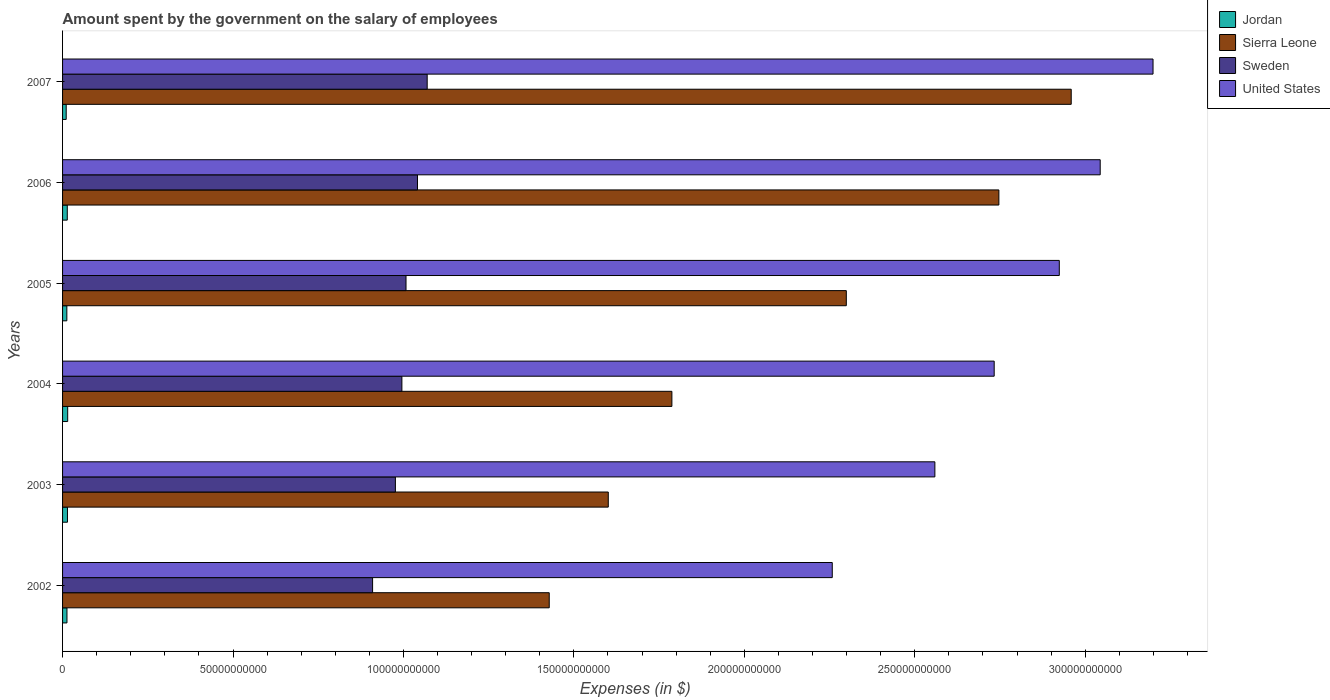How many bars are there on the 4th tick from the top?
Offer a terse response. 4. How many bars are there on the 5th tick from the bottom?
Provide a short and direct response. 4. What is the amount spent on the salary of employees by the government in Jordan in 2006?
Your response must be concise. 1.38e+09. Across all years, what is the maximum amount spent on the salary of employees by the government in Sierra Leone?
Give a very brief answer. 2.96e+11. Across all years, what is the minimum amount spent on the salary of employees by the government in Sweden?
Offer a terse response. 9.09e+1. What is the total amount spent on the salary of employees by the government in Sweden in the graph?
Your answer should be compact. 6.00e+11. What is the difference between the amount spent on the salary of employees by the government in United States in 2002 and that in 2005?
Your answer should be very brief. -6.66e+1. What is the difference between the amount spent on the salary of employees by the government in Sweden in 2004 and the amount spent on the salary of employees by the government in Jordan in 2005?
Keep it short and to the point. 9.83e+1. What is the average amount spent on the salary of employees by the government in Sweden per year?
Offer a terse response. 1.00e+11. In the year 2002, what is the difference between the amount spent on the salary of employees by the government in United States and amount spent on the salary of employees by the government in Sierra Leone?
Offer a very short reply. 8.30e+1. What is the ratio of the amount spent on the salary of employees by the government in Sweden in 2002 to that in 2006?
Ensure brevity in your answer.  0.87. Is the difference between the amount spent on the salary of employees by the government in United States in 2004 and 2007 greater than the difference between the amount spent on the salary of employees by the government in Sierra Leone in 2004 and 2007?
Keep it short and to the point. Yes. What is the difference between the highest and the second highest amount spent on the salary of employees by the government in Jordan?
Keep it short and to the point. 6.46e+07. What is the difference between the highest and the lowest amount spent on the salary of employees by the government in United States?
Provide a succinct answer. 9.41e+1. In how many years, is the amount spent on the salary of employees by the government in Sweden greater than the average amount spent on the salary of employees by the government in Sweden taken over all years?
Provide a succinct answer. 3. What does the 1st bar from the top in 2002 represents?
Your answer should be very brief. United States. Is it the case that in every year, the sum of the amount spent on the salary of employees by the government in Sweden and amount spent on the salary of employees by the government in Jordan is greater than the amount spent on the salary of employees by the government in Sierra Leone?
Offer a very short reply. No. How many years are there in the graph?
Offer a terse response. 6. Does the graph contain any zero values?
Your response must be concise. No. Does the graph contain grids?
Give a very brief answer. No. How many legend labels are there?
Give a very brief answer. 4. What is the title of the graph?
Your answer should be compact. Amount spent by the government on the salary of employees. Does "Guatemala" appear as one of the legend labels in the graph?
Keep it short and to the point. No. What is the label or title of the X-axis?
Your answer should be very brief. Expenses (in $). What is the Expenses (in $) of Jordan in 2002?
Make the answer very short. 1.29e+09. What is the Expenses (in $) of Sierra Leone in 2002?
Your answer should be compact. 1.43e+11. What is the Expenses (in $) of Sweden in 2002?
Provide a succinct answer. 9.09e+1. What is the Expenses (in $) of United States in 2002?
Your answer should be very brief. 2.26e+11. What is the Expenses (in $) in Jordan in 2003?
Your answer should be very brief. 1.44e+09. What is the Expenses (in $) of Sierra Leone in 2003?
Provide a succinct answer. 1.60e+11. What is the Expenses (in $) of Sweden in 2003?
Ensure brevity in your answer.  9.76e+1. What is the Expenses (in $) in United States in 2003?
Your answer should be compact. 2.56e+11. What is the Expenses (in $) in Jordan in 2004?
Your answer should be very brief. 1.50e+09. What is the Expenses (in $) of Sierra Leone in 2004?
Your answer should be compact. 1.79e+11. What is the Expenses (in $) in Sweden in 2004?
Provide a short and direct response. 9.95e+1. What is the Expenses (in $) of United States in 2004?
Your response must be concise. 2.73e+11. What is the Expenses (in $) of Jordan in 2005?
Your answer should be compact. 1.25e+09. What is the Expenses (in $) in Sierra Leone in 2005?
Offer a terse response. 2.30e+11. What is the Expenses (in $) in Sweden in 2005?
Offer a terse response. 1.01e+11. What is the Expenses (in $) in United States in 2005?
Offer a terse response. 2.92e+11. What is the Expenses (in $) in Jordan in 2006?
Make the answer very short. 1.38e+09. What is the Expenses (in $) in Sierra Leone in 2006?
Provide a short and direct response. 2.75e+11. What is the Expenses (in $) in Sweden in 2006?
Provide a succinct answer. 1.04e+11. What is the Expenses (in $) in United States in 2006?
Your response must be concise. 3.04e+11. What is the Expenses (in $) in Jordan in 2007?
Offer a terse response. 1.07e+09. What is the Expenses (in $) of Sierra Leone in 2007?
Provide a short and direct response. 2.96e+11. What is the Expenses (in $) of Sweden in 2007?
Make the answer very short. 1.07e+11. What is the Expenses (in $) in United States in 2007?
Give a very brief answer. 3.20e+11. Across all years, what is the maximum Expenses (in $) of Jordan?
Make the answer very short. 1.50e+09. Across all years, what is the maximum Expenses (in $) in Sierra Leone?
Provide a short and direct response. 2.96e+11. Across all years, what is the maximum Expenses (in $) in Sweden?
Your answer should be compact. 1.07e+11. Across all years, what is the maximum Expenses (in $) of United States?
Ensure brevity in your answer.  3.20e+11. Across all years, what is the minimum Expenses (in $) of Jordan?
Keep it short and to the point. 1.07e+09. Across all years, what is the minimum Expenses (in $) of Sierra Leone?
Offer a very short reply. 1.43e+11. Across all years, what is the minimum Expenses (in $) in Sweden?
Offer a very short reply. 9.09e+1. Across all years, what is the minimum Expenses (in $) of United States?
Offer a terse response. 2.26e+11. What is the total Expenses (in $) of Jordan in the graph?
Give a very brief answer. 7.93e+09. What is the total Expenses (in $) in Sierra Leone in the graph?
Provide a succinct answer. 1.28e+12. What is the total Expenses (in $) in Sweden in the graph?
Make the answer very short. 6.00e+11. What is the total Expenses (in $) of United States in the graph?
Provide a succinct answer. 1.67e+12. What is the difference between the Expenses (in $) of Jordan in 2002 and that in 2003?
Your answer should be very brief. -1.46e+08. What is the difference between the Expenses (in $) in Sierra Leone in 2002 and that in 2003?
Make the answer very short. -1.73e+1. What is the difference between the Expenses (in $) of Sweden in 2002 and that in 2003?
Make the answer very short. -6.69e+09. What is the difference between the Expenses (in $) of United States in 2002 and that in 2003?
Your response must be concise. -3.01e+1. What is the difference between the Expenses (in $) of Jordan in 2002 and that in 2004?
Your answer should be compact. -2.10e+08. What is the difference between the Expenses (in $) in Sierra Leone in 2002 and that in 2004?
Provide a short and direct response. -3.60e+1. What is the difference between the Expenses (in $) in Sweden in 2002 and that in 2004?
Ensure brevity in your answer.  -8.60e+09. What is the difference between the Expenses (in $) in United States in 2002 and that in 2004?
Offer a very short reply. -4.75e+1. What is the difference between the Expenses (in $) in Jordan in 2002 and that in 2005?
Your answer should be compact. 3.66e+07. What is the difference between the Expenses (in $) in Sierra Leone in 2002 and that in 2005?
Provide a succinct answer. -8.72e+1. What is the difference between the Expenses (in $) of Sweden in 2002 and that in 2005?
Your answer should be compact. -9.81e+09. What is the difference between the Expenses (in $) of United States in 2002 and that in 2005?
Your response must be concise. -6.66e+1. What is the difference between the Expenses (in $) of Jordan in 2002 and that in 2006?
Your answer should be compact. -9.21e+07. What is the difference between the Expenses (in $) in Sierra Leone in 2002 and that in 2006?
Provide a short and direct response. -1.32e+11. What is the difference between the Expenses (in $) in Sweden in 2002 and that in 2006?
Offer a very short reply. -1.32e+1. What is the difference between the Expenses (in $) in United States in 2002 and that in 2006?
Provide a short and direct response. -7.86e+1. What is the difference between the Expenses (in $) in Jordan in 2002 and that in 2007?
Ensure brevity in your answer.  2.23e+08. What is the difference between the Expenses (in $) of Sierra Leone in 2002 and that in 2007?
Keep it short and to the point. -1.53e+11. What is the difference between the Expenses (in $) in Sweden in 2002 and that in 2007?
Your answer should be very brief. -1.60e+1. What is the difference between the Expenses (in $) of United States in 2002 and that in 2007?
Keep it short and to the point. -9.41e+1. What is the difference between the Expenses (in $) in Jordan in 2003 and that in 2004?
Your answer should be compact. -6.46e+07. What is the difference between the Expenses (in $) in Sierra Leone in 2003 and that in 2004?
Provide a short and direct response. -1.87e+1. What is the difference between the Expenses (in $) in Sweden in 2003 and that in 2004?
Your response must be concise. -1.91e+09. What is the difference between the Expenses (in $) of United States in 2003 and that in 2004?
Offer a terse response. -1.74e+1. What is the difference between the Expenses (in $) in Jordan in 2003 and that in 2005?
Your answer should be compact. 1.82e+08. What is the difference between the Expenses (in $) in Sierra Leone in 2003 and that in 2005?
Provide a succinct answer. -6.98e+1. What is the difference between the Expenses (in $) in Sweden in 2003 and that in 2005?
Make the answer very short. -3.12e+09. What is the difference between the Expenses (in $) of United States in 2003 and that in 2005?
Make the answer very short. -3.65e+1. What is the difference between the Expenses (in $) in Jordan in 2003 and that in 2006?
Your answer should be very brief. 5.34e+07. What is the difference between the Expenses (in $) in Sierra Leone in 2003 and that in 2006?
Keep it short and to the point. -1.15e+11. What is the difference between the Expenses (in $) of Sweden in 2003 and that in 2006?
Provide a succinct answer. -6.48e+09. What is the difference between the Expenses (in $) in United States in 2003 and that in 2006?
Keep it short and to the point. -4.85e+1. What is the difference between the Expenses (in $) in Jordan in 2003 and that in 2007?
Make the answer very short. 3.69e+08. What is the difference between the Expenses (in $) in Sierra Leone in 2003 and that in 2007?
Offer a very short reply. -1.36e+11. What is the difference between the Expenses (in $) in Sweden in 2003 and that in 2007?
Ensure brevity in your answer.  -9.33e+09. What is the difference between the Expenses (in $) in United States in 2003 and that in 2007?
Your response must be concise. -6.40e+1. What is the difference between the Expenses (in $) in Jordan in 2004 and that in 2005?
Offer a very short reply. 2.47e+08. What is the difference between the Expenses (in $) in Sierra Leone in 2004 and that in 2005?
Your answer should be compact. -5.12e+1. What is the difference between the Expenses (in $) of Sweden in 2004 and that in 2005?
Offer a terse response. -1.21e+09. What is the difference between the Expenses (in $) in United States in 2004 and that in 2005?
Provide a short and direct response. -1.91e+1. What is the difference between the Expenses (in $) of Jordan in 2004 and that in 2006?
Ensure brevity in your answer.  1.18e+08. What is the difference between the Expenses (in $) of Sierra Leone in 2004 and that in 2006?
Your answer should be compact. -9.59e+1. What is the difference between the Expenses (in $) of Sweden in 2004 and that in 2006?
Your answer should be compact. -4.57e+09. What is the difference between the Expenses (in $) of United States in 2004 and that in 2006?
Provide a short and direct response. -3.11e+1. What is the difference between the Expenses (in $) in Jordan in 2004 and that in 2007?
Your answer should be very brief. 4.33e+08. What is the difference between the Expenses (in $) of Sierra Leone in 2004 and that in 2007?
Keep it short and to the point. -1.17e+11. What is the difference between the Expenses (in $) in Sweden in 2004 and that in 2007?
Give a very brief answer. -7.42e+09. What is the difference between the Expenses (in $) in United States in 2004 and that in 2007?
Make the answer very short. -4.66e+1. What is the difference between the Expenses (in $) of Jordan in 2005 and that in 2006?
Your answer should be compact. -1.29e+08. What is the difference between the Expenses (in $) of Sierra Leone in 2005 and that in 2006?
Make the answer very short. -4.48e+1. What is the difference between the Expenses (in $) in Sweden in 2005 and that in 2006?
Make the answer very short. -3.36e+09. What is the difference between the Expenses (in $) in United States in 2005 and that in 2006?
Make the answer very short. -1.20e+1. What is the difference between the Expenses (in $) in Jordan in 2005 and that in 2007?
Keep it short and to the point. 1.86e+08. What is the difference between the Expenses (in $) of Sierra Leone in 2005 and that in 2007?
Your response must be concise. -6.60e+1. What is the difference between the Expenses (in $) of Sweden in 2005 and that in 2007?
Make the answer very short. -6.21e+09. What is the difference between the Expenses (in $) in United States in 2005 and that in 2007?
Provide a succinct answer. -2.75e+1. What is the difference between the Expenses (in $) in Jordan in 2006 and that in 2007?
Ensure brevity in your answer.  3.15e+08. What is the difference between the Expenses (in $) in Sierra Leone in 2006 and that in 2007?
Provide a short and direct response. -2.12e+1. What is the difference between the Expenses (in $) in Sweden in 2006 and that in 2007?
Your response must be concise. -2.85e+09. What is the difference between the Expenses (in $) in United States in 2006 and that in 2007?
Provide a succinct answer. -1.55e+1. What is the difference between the Expenses (in $) of Jordan in 2002 and the Expenses (in $) of Sierra Leone in 2003?
Keep it short and to the point. -1.59e+11. What is the difference between the Expenses (in $) of Jordan in 2002 and the Expenses (in $) of Sweden in 2003?
Ensure brevity in your answer.  -9.63e+1. What is the difference between the Expenses (in $) in Jordan in 2002 and the Expenses (in $) in United States in 2003?
Your answer should be compact. -2.55e+11. What is the difference between the Expenses (in $) of Sierra Leone in 2002 and the Expenses (in $) of Sweden in 2003?
Your response must be concise. 4.51e+1. What is the difference between the Expenses (in $) in Sierra Leone in 2002 and the Expenses (in $) in United States in 2003?
Give a very brief answer. -1.13e+11. What is the difference between the Expenses (in $) in Sweden in 2002 and the Expenses (in $) in United States in 2003?
Your answer should be compact. -1.65e+11. What is the difference between the Expenses (in $) of Jordan in 2002 and the Expenses (in $) of Sierra Leone in 2004?
Ensure brevity in your answer.  -1.77e+11. What is the difference between the Expenses (in $) of Jordan in 2002 and the Expenses (in $) of Sweden in 2004?
Make the answer very short. -9.83e+1. What is the difference between the Expenses (in $) of Jordan in 2002 and the Expenses (in $) of United States in 2004?
Offer a very short reply. -2.72e+11. What is the difference between the Expenses (in $) in Sierra Leone in 2002 and the Expenses (in $) in Sweden in 2004?
Your answer should be very brief. 4.32e+1. What is the difference between the Expenses (in $) in Sierra Leone in 2002 and the Expenses (in $) in United States in 2004?
Your answer should be compact. -1.31e+11. What is the difference between the Expenses (in $) in Sweden in 2002 and the Expenses (in $) in United States in 2004?
Your answer should be compact. -1.82e+11. What is the difference between the Expenses (in $) in Jordan in 2002 and the Expenses (in $) in Sierra Leone in 2005?
Offer a very short reply. -2.29e+11. What is the difference between the Expenses (in $) of Jordan in 2002 and the Expenses (in $) of Sweden in 2005?
Provide a short and direct response. -9.95e+1. What is the difference between the Expenses (in $) of Jordan in 2002 and the Expenses (in $) of United States in 2005?
Ensure brevity in your answer.  -2.91e+11. What is the difference between the Expenses (in $) of Sierra Leone in 2002 and the Expenses (in $) of Sweden in 2005?
Ensure brevity in your answer.  4.20e+1. What is the difference between the Expenses (in $) of Sierra Leone in 2002 and the Expenses (in $) of United States in 2005?
Your response must be concise. -1.50e+11. What is the difference between the Expenses (in $) of Sweden in 2002 and the Expenses (in $) of United States in 2005?
Make the answer very short. -2.01e+11. What is the difference between the Expenses (in $) in Jordan in 2002 and the Expenses (in $) in Sierra Leone in 2006?
Your answer should be very brief. -2.73e+11. What is the difference between the Expenses (in $) of Jordan in 2002 and the Expenses (in $) of Sweden in 2006?
Offer a terse response. -1.03e+11. What is the difference between the Expenses (in $) in Jordan in 2002 and the Expenses (in $) in United States in 2006?
Provide a short and direct response. -3.03e+11. What is the difference between the Expenses (in $) in Sierra Leone in 2002 and the Expenses (in $) in Sweden in 2006?
Give a very brief answer. 3.87e+1. What is the difference between the Expenses (in $) in Sierra Leone in 2002 and the Expenses (in $) in United States in 2006?
Offer a very short reply. -1.62e+11. What is the difference between the Expenses (in $) of Sweden in 2002 and the Expenses (in $) of United States in 2006?
Your response must be concise. -2.13e+11. What is the difference between the Expenses (in $) in Jordan in 2002 and the Expenses (in $) in Sierra Leone in 2007?
Offer a very short reply. -2.95e+11. What is the difference between the Expenses (in $) of Jordan in 2002 and the Expenses (in $) of Sweden in 2007?
Give a very brief answer. -1.06e+11. What is the difference between the Expenses (in $) in Jordan in 2002 and the Expenses (in $) in United States in 2007?
Your answer should be very brief. -3.19e+11. What is the difference between the Expenses (in $) of Sierra Leone in 2002 and the Expenses (in $) of Sweden in 2007?
Make the answer very short. 3.58e+1. What is the difference between the Expenses (in $) of Sierra Leone in 2002 and the Expenses (in $) of United States in 2007?
Your answer should be compact. -1.77e+11. What is the difference between the Expenses (in $) of Sweden in 2002 and the Expenses (in $) of United States in 2007?
Your answer should be very brief. -2.29e+11. What is the difference between the Expenses (in $) in Jordan in 2003 and the Expenses (in $) in Sierra Leone in 2004?
Make the answer very short. -1.77e+11. What is the difference between the Expenses (in $) of Jordan in 2003 and the Expenses (in $) of Sweden in 2004?
Provide a short and direct response. -9.81e+1. What is the difference between the Expenses (in $) in Jordan in 2003 and the Expenses (in $) in United States in 2004?
Provide a short and direct response. -2.72e+11. What is the difference between the Expenses (in $) of Sierra Leone in 2003 and the Expenses (in $) of Sweden in 2004?
Give a very brief answer. 6.05e+1. What is the difference between the Expenses (in $) in Sierra Leone in 2003 and the Expenses (in $) in United States in 2004?
Provide a succinct answer. -1.13e+11. What is the difference between the Expenses (in $) in Sweden in 2003 and the Expenses (in $) in United States in 2004?
Give a very brief answer. -1.76e+11. What is the difference between the Expenses (in $) of Jordan in 2003 and the Expenses (in $) of Sierra Leone in 2005?
Provide a short and direct response. -2.28e+11. What is the difference between the Expenses (in $) in Jordan in 2003 and the Expenses (in $) in Sweden in 2005?
Your answer should be very brief. -9.93e+1. What is the difference between the Expenses (in $) of Jordan in 2003 and the Expenses (in $) of United States in 2005?
Offer a terse response. -2.91e+11. What is the difference between the Expenses (in $) of Sierra Leone in 2003 and the Expenses (in $) of Sweden in 2005?
Give a very brief answer. 5.93e+1. What is the difference between the Expenses (in $) of Sierra Leone in 2003 and the Expenses (in $) of United States in 2005?
Provide a short and direct response. -1.32e+11. What is the difference between the Expenses (in $) in Sweden in 2003 and the Expenses (in $) in United States in 2005?
Your answer should be very brief. -1.95e+11. What is the difference between the Expenses (in $) in Jordan in 2003 and the Expenses (in $) in Sierra Leone in 2006?
Your answer should be compact. -2.73e+11. What is the difference between the Expenses (in $) of Jordan in 2003 and the Expenses (in $) of Sweden in 2006?
Ensure brevity in your answer.  -1.03e+11. What is the difference between the Expenses (in $) of Jordan in 2003 and the Expenses (in $) of United States in 2006?
Provide a succinct answer. -3.03e+11. What is the difference between the Expenses (in $) of Sierra Leone in 2003 and the Expenses (in $) of Sweden in 2006?
Keep it short and to the point. 5.60e+1. What is the difference between the Expenses (in $) of Sierra Leone in 2003 and the Expenses (in $) of United States in 2006?
Keep it short and to the point. -1.44e+11. What is the difference between the Expenses (in $) of Sweden in 2003 and the Expenses (in $) of United States in 2006?
Make the answer very short. -2.07e+11. What is the difference between the Expenses (in $) in Jordan in 2003 and the Expenses (in $) in Sierra Leone in 2007?
Offer a very short reply. -2.94e+11. What is the difference between the Expenses (in $) of Jordan in 2003 and the Expenses (in $) of Sweden in 2007?
Ensure brevity in your answer.  -1.06e+11. What is the difference between the Expenses (in $) of Jordan in 2003 and the Expenses (in $) of United States in 2007?
Make the answer very short. -3.18e+11. What is the difference between the Expenses (in $) of Sierra Leone in 2003 and the Expenses (in $) of Sweden in 2007?
Ensure brevity in your answer.  5.31e+1. What is the difference between the Expenses (in $) of Sierra Leone in 2003 and the Expenses (in $) of United States in 2007?
Provide a succinct answer. -1.60e+11. What is the difference between the Expenses (in $) of Sweden in 2003 and the Expenses (in $) of United States in 2007?
Your answer should be compact. -2.22e+11. What is the difference between the Expenses (in $) of Jordan in 2004 and the Expenses (in $) of Sierra Leone in 2005?
Offer a terse response. -2.28e+11. What is the difference between the Expenses (in $) of Jordan in 2004 and the Expenses (in $) of Sweden in 2005?
Make the answer very short. -9.93e+1. What is the difference between the Expenses (in $) of Jordan in 2004 and the Expenses (in $) of United States in 2005?
Give a very brief answer. -2.91e+11. What is the difference between the Expenses (in $) in Sierra Leone in 2004 and the Expenses (in $) in Sweden in 2005?
Your answer should be compact. 7.80e+1. What is the difference between the Expenses (in $) in Sierra Leone in 2004 and the Expenses (in $) in United States in 2005?
Give a very brief answer. -1.14e+11. What is the difference between the Expenses (in $) of Sweden in 2004 and the Expenses (in $) of United States in 2005?
Your answer should be compact. -1.93e+11. What is the difference between the Expenses (in $) of Jordan in 2004 and the Expenses (in $) of Sierra Leone in 2006?
Offer a terse response. -2.73e+11. What is the difference between the Expenses (in $) in Jordan in 2004 and the Expenses (in $) in Sweden in 2006?
Offer a very short reply. -1.03e+11. What is the difference between the Expenses (in $) of Jordan in 2004 and the Expenses (in $) of United States in 2006?
Offer a terse response. -3.03e+11. What is the difference between the Expenses (in $) in Sierra Leone in 2004 and the Expenses (in $) in Sweden in 2006?
Keep it short and to the point. 7.46e+1. What is the difference between the Expenses (in $) in Sierra Leone in 2004 and the Expenses (in $) in United States in 2006?
Your answer should be very brief. -1.26e+11. What is the difference between the Expenses (in $) in Sweden in 2004 and the Expenses (in $) in United States in 2006?
Give a very brief answer. -2.05e+11. What is the difference between the Expenses (in $) of Jordan in 2004 and the Expenses (in $) of Sierra Leone in 2007?
Offer a terse response. -2.94e+11. What is the difference between the Expenses (in $) of Jordan in 2004 and the Expenses (in $) of Sweden in 2007?
Provide a short and direct response. -1.05e+11. What is the difference between the Expenses (in $) of Jordan in 2004 and the Expenses (in $) of United States in 2007?
Keep it short and to the point. -3.18e+11. What is the difference between the Expenses (in $) in Sierra Leone in 2004 and the Expenses (in $) in Sweden in 2007?
Ensure brevity in your answer.  7.18e+1. What is the difference between the Expenses (in $) in Sierra Leone in 2004 and the Expenses (in $) in United States in 2007?
Offer a terse response. -1.41e+11. What is the difference between the Expenses (in $) of Sweden in 2004 and the Expenses (in $) of United States in 2007?
Offer a terse response. -2.20e+11. What is the difference between the Expenses (in $) of Jordan in 2005 and the Expenses (in $) of Sierra Leone in 2006?
Make the answer very short. -2.73e+11. What is the difference between the Expenses (in $) of Jordan in 2005 and the Expenses (in $) of Sweden in 2006?
Your answer should be compact. -1.03e+11. What is the difference between the Expenses (in $) of Jordan in 2005 and the Expenses (in $) of United States in 2006?
Provide a short and direct response. -3.03e+11. What is the difference between the Expenses (in $) of Sierra Leone in 2005 and the Expenses (in $) of Sweden in 2006?
Make the answer very short. 1.26e+11. What is the difference between the Expenses (in $) of Sierra Leone in 2005 and the Expenses (in $) of United States in 2006?
Your response must be concise. -7.45e+1. What is the difference between the Expenses (in $) in Sweden in 2005 and the Expenses (in $) in United States in 2006?
Ensure brevity in your answer.  -2.04e+11. What is the difference between the Expenses (in $) of Jordan in 2005 and the Expenses (in $) of Sierra Leone in 2007?
Offer a terse response. -2.95e+11. What is the difference between the Expenses (in $) of Jordan in 2005 and the Expenses (in $) of Sweden in 2007?
Your response must be concise. -1.06e+11. What is the difference between the Expenses (in $) of Jordan in 2005 and the Expenses (in $) of United States in 2007?
Provide a short and direct response. -3.19e+11. What is the difference between the Expenses (in $) of Sierra Leone in 2005 and the Expenses (in $) of Sweden in 2007?
Keep it short and to the point. 1.23e+11. What is the difference between the Expenses (in $) in Sierra Leone in 2005 and the Expenses (in $) in United States in 2007?
Provide a short and direct response. -9.00e+1. What is the difference between the Expenses (in $) in Sweden in 2005 and the Expenses (in $) in United States in 2007?
Keep it short and to the point. -2.19e+11. What is the difference between the Expenses (in $) of Jordan in 2006 and the Expenses (in $) of Sierra Leone in 2007?
Give a very brief answer. -2.95e+11. What is the difference between the Expenses (in $) in Jordan in 2006 and the Expenses (in $) in Sweden in 2007?
Offer a very short reply. -1.06e+11. What is the difference between the Expenses (in $) in Jordan in 2006 and the Expenses (in $) in United States in 2007?
Give a very brief answer. -3.19e+11. What is the difference between the Expenses (in $) in Sierra Leone in 2006 and the Expenses (in $) in Sweden in 2007?
Your answer should be very brief. 1.68e+11. What is the difference between the Expenses (in $) of Sierra Leone in 2006 and the Expenses (in $) of United States in 2007?
Your answer should be compact. -4.52e+1. What is the difference between the Expenses (in $) of Sweden in 2006 and the Expenses (in $) of United States in 2007?
Give a very brief answer. -2.16e+11. What is the average Expenses (in $) in Jordan per year?
Provide a succinct answer. 1.32e+09. What is the average Expenses (in $) in Sierra Leone per year?
Your answer should be very brief. 2.14e+11. What is the average Expenses (in $) in Sweden per year?
Make the answer very short. 1.00e+11. What is the average Expenses (in $) in United States per year?
Ensure brevity in your answer.  2.79e+11. In the year 2002, what is the difference between the Expenses (in $) in Jordan and Expenses (in $) in Sierra Leone?
Your response must be concise. -1.41e+11. In the year 2002, what is the difference between the Expenses (in $) of Jordan and Expenses (in $) of Sweden?
Your answer should be very brief. -8.97e+1. In the year 2002, what is the difference between the Expenses (in $) in Jordan and Expenses (in $) in United States?
Give a very brief answer. -2.25e+11. In the year 2002, what is the difference between the Expenses (in $) in Sierra Leone and Expenses (in $) in Sweden?
Keep it short and to the point. 5.18e+1. In the year 2002, what is the difference between the Expenses (in $) in Sierra Leone and Expenses (in $) in United States?
Provide a short and direct response. -8.30e+1. In the year 2002, what is the difference between the Expenses (in $) of Sweden and Expenses (in $) of United States?
Your response must be concise. -1.35e+11. In the year 2003, what is the difference between the Expenses (in $) in Jordan and Expenses (in $) in Sierra Leone?
Provide a short and direct response. -1.59e+11. In the year 2003, what is the difference between the Expenses (in $) of Jordan and Expenses (in $) of Sweden?
Your answer should be compact. -9.62e+1. In the year 2003, what is the difference between the Expenses (in $) in Jordan and Expenses (in $) in United States?
Give a very brief answer. -2.54e+11. In the year 2003, what is the difference between the Expenses (in $) in Sierra Leone and Expenses (in $) in Sweden?
Make the answer very short. 6.25e+1. In the year 2003, what is the difference between the Expenses (in $) in Sierra Leone and Expenses (in $) in United States?
Provide a short and direct response. -9.58e+1. In the year 2003, what is the difference between the Expenses (in $) of Sweden and Expenses (in $) of United States?
Provide a succinct answer. -1.58e+11. In the year 2004, what is the difference between the Expenses (in $) in Jordan and Expenses (in $) in Sierra Leone?
Your answer should be very brief. -1.77e+11. In the year 2004, what is the difference between the Expenses (in $) in Jordan and Expenses (in $) in Sweden?
Keep it short and to the point. -9.80e+1. In the year 2004, what is the difference between the Expenses (in $) in Jordan and Expenses (in $) in United States?
Your answer should be very brief. -2.72e+11. In the year 2004, what is the difference between the Expenses (in $) in Sierra Leone and Expenses (in $) in Sweden?
Your answer should be compact. 7.92e+1. In the year 2004, what is the difference between the Expenses (in $) in Sierra Leone and Expenses (in $) in United States?
Your answer should be compact. -9.45e+1. In the year 2004, what is the difference between the Expenses (in $) of Sweden and Expenses (in $) of United States?
Your answer should be compact. -1.74e+11. In the year 2005, what is the difference between the Expenses (in $) in Jordan and Expenses (in $) in Sierra Leone?
Keep it short and to the point. -2.29e+11. In the year 2005, what is the difference between the Expenses (in $) in Jordan and Expenses (in $) in Sweden?
Provide a succinct answer. -9.95e+1. In the year 2005, what is the difference between the Expenses (in $) of Jordan and Expenses (in $) of United States?
Ensure brevity in your answer.  -2.91e+11. In the year 2005, what is the difference between the Expenses (in $) in Sierra Leone and Expenses (in $) in Sweden?
Provide a succinct answer. 1.29e+11. In the year 2005, what is the difference between the Expenses (in $) of Sierra Leone and Expenses (in $) of United States?
Offer a terse response. -6.25e+1. In the year 2005, what is the difference between the Expenses (in $) of Sweden and Expenses (in $) of United States?
Provide a succinct answer. -1.92e+11. In the year 2006, what is the difference between the Expenses (in $) of Jordan and Expenses (in $) of Sierra Leone?
Make the answer very short. -2.73e+11. In the year 2006, what is the difference between the Expenses (in $) in Jordan and Expenses (in $) in Sweden?
Offer a very short reply. -1.03e+11. In the year 2006, what is the difference between the Expenses (in $) of Jordan and Expenses (in $) of United States?
Provide a succinct answer. -3.03e+11. In the year 2006, what is the difference between the Expenses (in $) in Sierra Leone and Expenses (in $) in Sweden?
Your response must be concise. 1.71e+11. In the year 2006, what is the difference between the Expenses (in $) in Sierra Leone and Expenses (in $) in United States?
Give a very brief answer. -2.97e+1. In the year 2006, what is the difference between the Expenses (in $) in Sweden and Expenses (in $) in United States?
Offer a terse response. -2.00e+11. In the year 2007, what is the difference between the Expenses (in $) of Jordan and Expenses (in $) of Sierra Leone?
Your response must be concise. -2.95e+11. In the year 2007, what is the difference between the Expenses (in $) in Jordan and Expenses (in $) in Sweden?
Make the answer very short. -1.06e+11. In the year 2007, what is the difference between the Expenses (in $) in Jordan and Expenses (in $) in United States?
Your answer should be very brief. -3.19e+11. In the year 2007, what is the difference between the Expenses (in $) in Sierra Leone and Expenses (in $) in Sweden?
Provide a succinct answer. 1.89e+11. In the year 2007, what is the difference between the Expenses (in $) of Sierra Leone and Expenses (in $) of United States?
Give a very brief answer. -2.40e+1. In the year 2007, what is the difference between the Expenses (in $) of Sweden and Expenses (in $) of United States?
Make the answer very short. -2.13e+11. What is the ratio of the Expenses (in $) in Jordan in 2002 to that in 2003?
Your response must be concise. 0.9. What is the ratio of the Expenses (in $) of Sierra Leone in 2002 to that in 2003?
Ensure brevity in your answer.  0.89. What is the ratio of the Expenses (in $) in Sweden in 2002 to that in 2003?
Your answer should be very brief. 0.93. What is the ratio of the Expenses (in $) in United States in 2002 to that in 2003?
Ensure brevity in your answer.  0.88. What is the ratio of the Expenses (in $) of Jordan in 2002 to that in 2004?
Give a very brief answer. 0.86. What is the ratio of the Expenses (in $) of Sierra Leone in 2002 to that in 2004?
Make the answer very short. 0.8. What is the ratio of the Expenses (in $) of Sweden in 2002 to that in 2004?
Your answer should be very brief. 0.91. What is the ratio of the Expenses (in $) in United States in 2002 to that in 2004?
Offer a terse response. 0.83. What is the ratio of the Expenses (in $) of Jordan in 2002 to that in 2005?
Provide a succinct answer. 1.03. What is the ratio of the Expenses (in $) of Sierra Leone in 2002 to that in 2005?
Your answer should be very brief. 0.62. What is the ratio of the Expenses (in $) in Sweden in 2002 to that in 2005?
Offer a very short reply. 0.9. What is the ratio of the Expenses (in $) of United States in 2002 to that in 2005?
Provide a succinct answer. 0.77. What is the ratio of the Expenses (in $) of Jordan in 2002 to that in 2006?
Your answer should be compact. 0.93. What is the ratio of the Expenses (in $) of Sierra Leone in 2002 to that in 2006?
Your answer should be very brief. 0.52. What is the ratio of the Expenses (in $) in Sweden in 2002 to that in 2006?
Offer a very short reply. 0.87. What is the ratio of the Expenses (in $) of United States in 2002 to that in 2006?
Provide a succinct answer. 0.74. What is the ratio of the Expenses (in $) of Jordan in 2002 to that in 2007?
Your answer should be very brief. 1.21. What is the ratio of the Expenses (in $) in Sierra Leone in 2002 to that in 2007?
Offer a terse response. 0.48. What is the ratio of the Expenses (in $) of Sweden in 2002 to that in 2007?
Your answer should be very brief. 0.85. What is the ratio of the Expenses (in $) of United States in 2002 to that in 2007?
Offer a very short reply. 0.71. What is the ratio of the Expenses (in $) in Jordan in 2003 to that in 2004?
Your response must be concise. 0.96. What is the ratio of the Expenses (in $) of Sierra Leone in 2003 to that in 2004?
Offer a terse response. 0.9. What is the ratio of the Expenses (in $) of Sweden in 2003 to that in 2004?
Keep it short and to the point. 0.98. What is the ratio of the Expenses (in $) of United States in 2003 to that in 2004?
Your response must be concise. 0.94. What is the ratio of the Expenses (in $) in Jordan in 2003 to that in 2005?
Offer a very short reply. 1.15. What is the ratio of the Expenses (in $) of Sierra Leone in 2003 to that in 2005?
Provide a succinct answer. 0.7. What is the ratio of the Expenses (in $) of Sweden in 2003 to that in 2005?
Provide a short and direct response. 0.97. What is the ratio of the Expenses (in $) in United States in 2003 to that in 2005?
Give a very brief answer. 0.88. What is the ratio of the Expenses (in $) in Jordan in 2003 to that in 2006?
Provide a short and direct response. 1.04. What is the ratio of the Expenses (in $) of Sierra Leone in 2003 to that in 2006?
Keep it short and to the point. 0.58. What is the ratio of the Expenses (in $) of Sweden in 2003 to that in 2006?
Offer a very short reply. 0.94. What is the ratio of the Expenses (in $) of United States in 2003 to that in 2006?
Provide a succinct answer. 0.84. What is the ratio of the Expenses (in $) of Jordan in 2003 to that in 2007?
Provide a short and direct response. 1.35. What is the ratio of the Expenses (in $) in Sierra Leone in 2003 to that in 2007?
Your response must be concise. 0.54. What is the ratio of the Expenses (in $) in Sweden in 2003 to that in 2007?
Offer a very short reply. 0.91. What is the ratio of the Expenses (in $) in United States in 2003 to that in 2007?
Give a very brief answer. 0.8. What is the ratio of the Expenses (in $) in Jordan in 2004 to that in 2005?
Offer a very short reply. 1.2. What is the ratio of the Expenses (in $) of Sierra Leone in 2004 to that in 2005?
Provide a succinct answer. 0.78. What is the ratio of the Expenses (in $) of Sweden in 2004 to that in 2005?
Your answer should be very brief. 0.99. What is the ratio of the Expenses (in $) in United States in 2004 to that in 2005?
Keep it short and to the point. 0.93. What is the ratio of the Expenses (in $) of Jordan in 2004 to that in 2006?
Your answer should be compact. 1.09. What is the ratio of the Expenses (in $) in Sierra Leone in 2004 to that in 2006?
Provide a succinct answer. 0.65. What is the ratio of the Expenses (in $) in Sweden in 2004 to that in 2006?
Give a very brief answer. 0.96. What is the ratio of the Expenses (in $) in United States in 2004 to that in 2006?
Offer a terse response. 0.9. What is the ratio of the Expenses (in $) in Jordan in 2004 to that in 2007?
Offer a terse response. 1.41. What is the ratio of the Expenses (in $) of Sierra Leone in 2004 to that in 2007?
Ensure brevity in your answer.  0.6. What is the ratio of the Expenses (in $) of Sweden in 2004 to that in 2007?
Your answer should be very brief. 0.93. What is the ratio of the Expenses (in $) of United States in 2004 to that in 2007?
Offer a very short reply. 0.85. What is the ratio of the Expenses (in $) in Jordan in 2005 to that in 2006?
Give a very brief answer. 0.91. What is the ratio of the Expenses (in $) of Sierra Leone in 2005 to that in 2006?
Your response must be concise. 0.84. What is the ratio of the Expenses (in $) in United States in 2005 to that in 2006?
Offer a very short reply. 0.96. What is the ratio of the Expenses (in $) of Jordan in 2005 to that in 2007?
Your response must be concise. 1.17. What is the ratio of the Expenses (in $) in Sierra Leone in 2005 to that in 2007?
Offer a terse response. 0.78. What is the ratio of the Expenses (in $) of Sweden in 2005 to that in 2007?
Provide a short and direct response. 0.94. What is the ratio of the Expenses (in $) in United States in 2005 to that in 2007?
Give a very brief answer. 0.91. What is the ratio of the Expenses (in $) of Jordan in 2006 to that in 2007?
Ensure brevity in your answer.  1.3. What is the ratio of the Expenses (in $) in Sierra Leone in 2006 to that in 2007?
Give a very brief answer. 0.93. What is the ratio of the Expenses (in $) of Sweden in 2006 to that in 2007?
Your response must be concise. 0.97. What is the ratio of the Expenses (in $) of United States in 2006 to that in 2007?
Offer a terse response. 0.95. What is the difference between the highest and the second highest Expenses (in $) of Jordan?
Provide a succinct answer. 6.46e+07. What is the difference between the highest and the second highest Expenses (in $) in Sierra Leone?
Offer a terse response. 2.12e+1. What is the difference between the highest and the second highest Expenses (in $) in Sweden?
Make the answer very short. 2.85e+09. What is the difference between the highest and the second highest Expenses (in $) in United States?
Offer a terse response. 1.55e+1. What is the difference between the highest and the lowest Expenses (in $) of Jordan?
Offer a terse response. 4.33e+08. What is the difference between the highest and the lowest Expenses (in $) of Sierra Leone?
Your answer should be very brief. 1.53e+11. What is the difference between the highest and the lowest Expenses (in $) in Sweden?
Offer a very short reply. 1.60e+1. What is the difference between the highest and the lowest Expenses (in $) in United States?
Keep it short and to the point. 9.41e+1. 